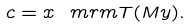<formula> <loc_0><loc_0><loc_500><loc_500>c = x ^ { \ } m r m { T } ( M y ) .</formula> 